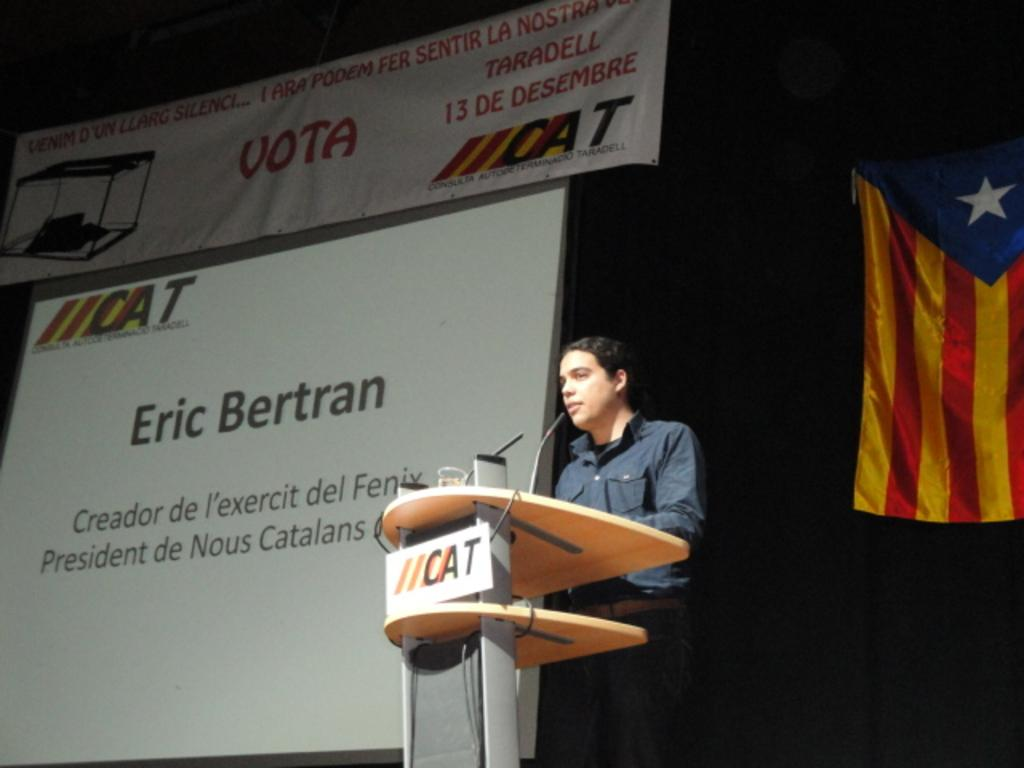What is the man in the image doing? There is a man standing in the image. What is the man wearing? The man is wearing a grey color shirt. What is in front of the man? There is a podium in front of the man. What can be seen in the background of the image? There is a banner, a screen, and a flag in the background of the image. What type of prose can be heard being read from the wall in the image? There is no prose or wall present in the image. What is the range of the flag in the image? There is no range mentioned or implied in the image; it simply shows a flag in the background. 